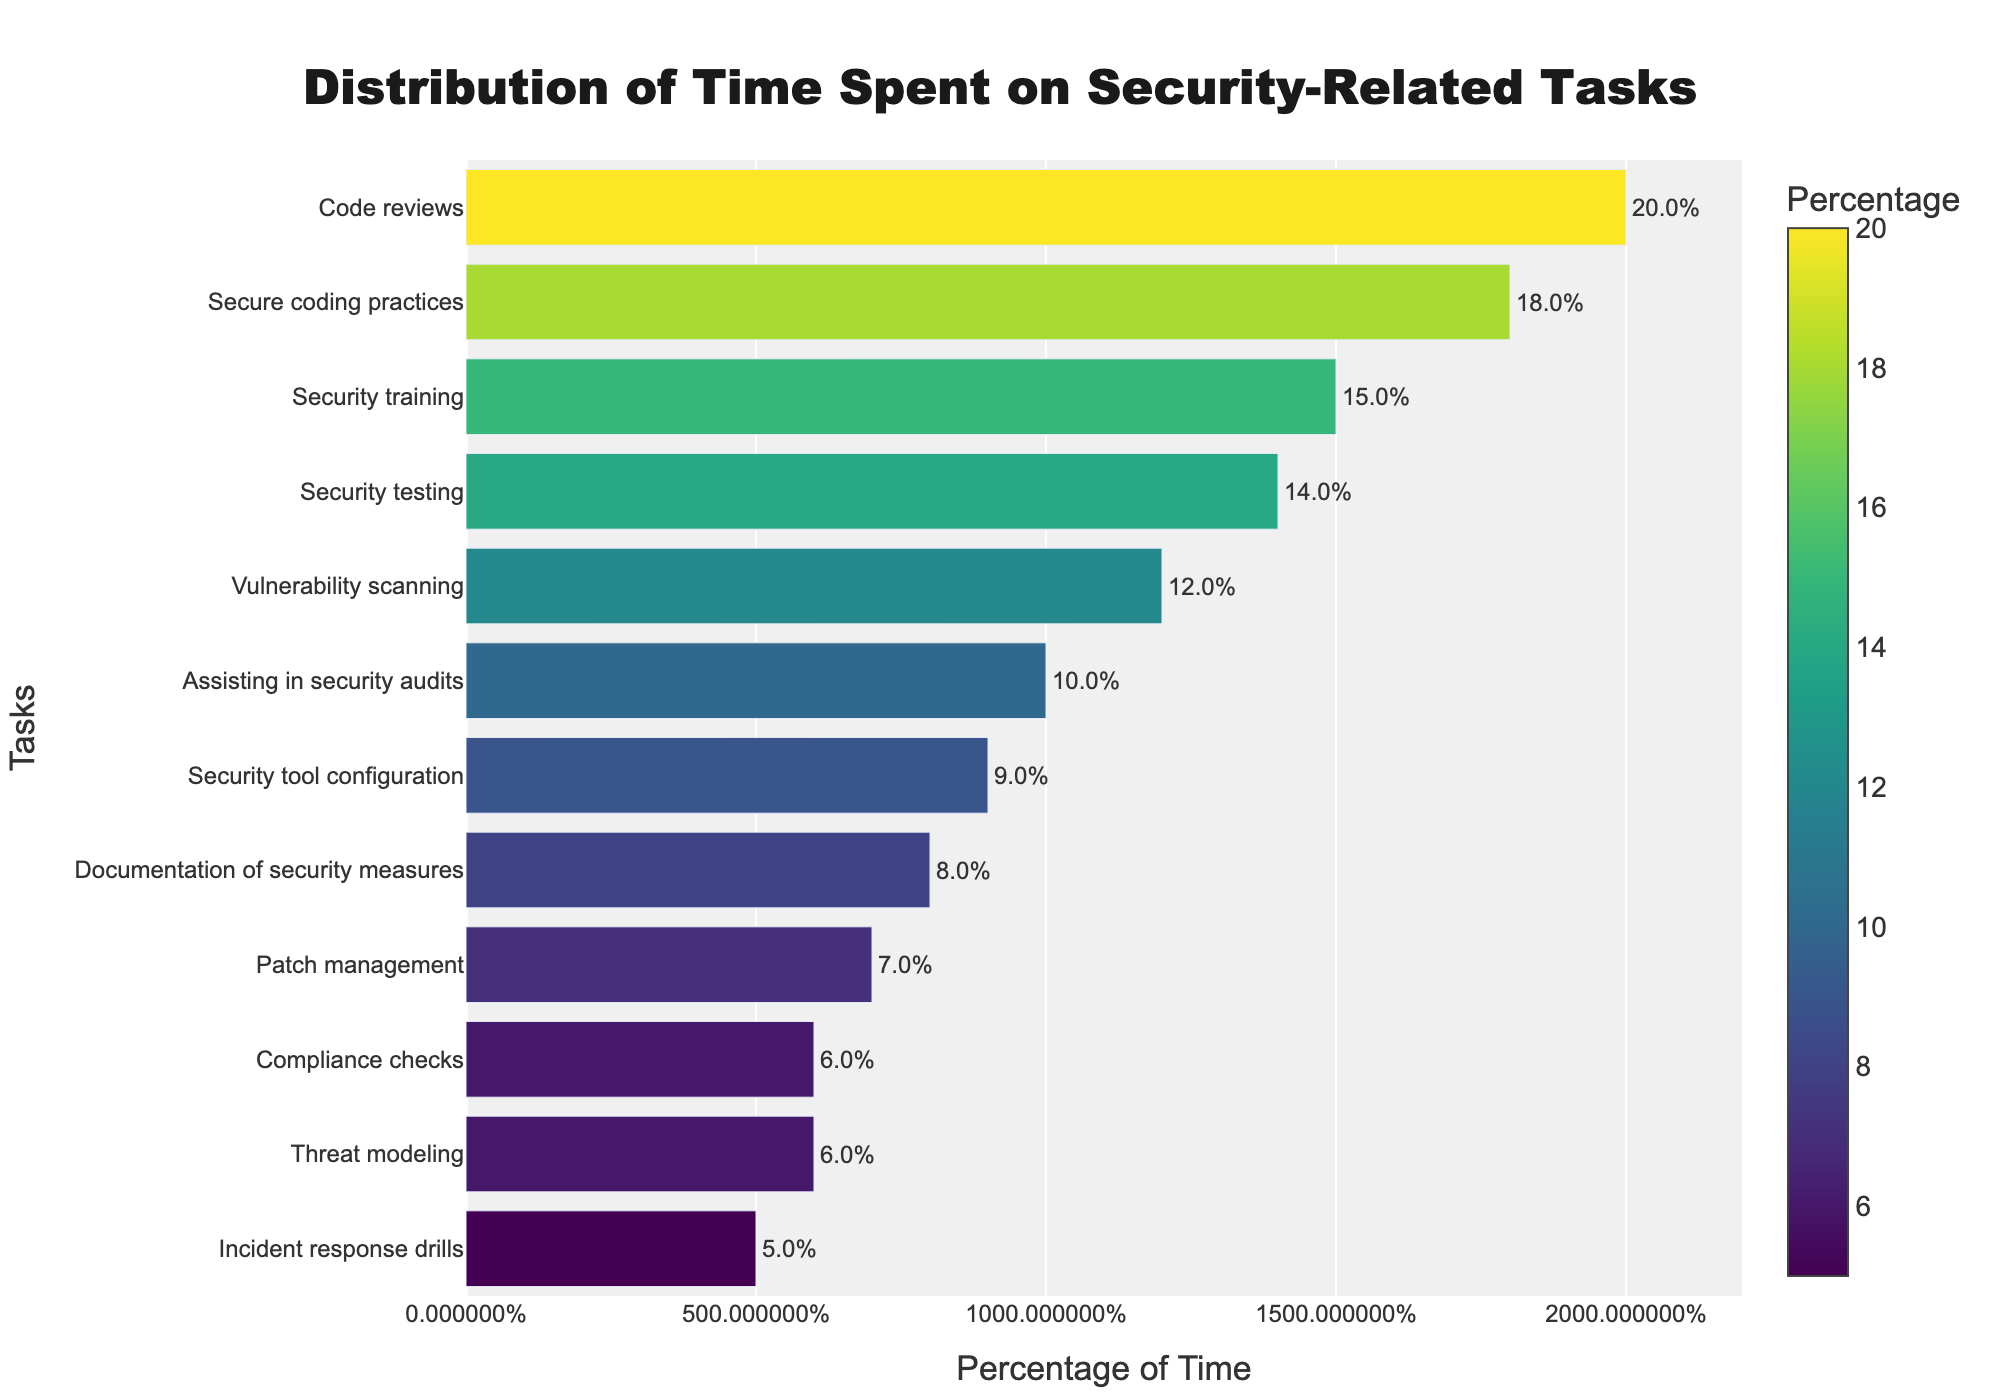what task consumes the most time? From the bar chart, the longest bar represents "Code reviews," which indicates the highest percentage.
Answer: Code reviews Rank the top three tasks based on the time spent. The three longest bars correspond to "Code reviews," "Secure coding practices," and "Security training" in descending order.
Answer: Code reviews, Secure coding practices, Security training Which tasks have the same percentage of time spent? By observing the lengths of the bars and their associated percentages, "Threat modeling" and "Compliance checks" both have a percentage of 6%.
Answer: Threat modeling, Compliance checks What is the combined percentage of time spent on "Security testing" and "Vulnerability scanning"? The bar representing "Security testing" shows 14%, and the bar for "Vulnerability scanning" shows 12%. Adding them together gives 14% + 12% = 26%.
Answer: 26% Which task requires less time: "Incident response drills" or "Patch management"? The bar for "Incident response drills" is shorter and shows 5%, whereas "Patch management" shows 7%. Thus, "Incident response drills" require less time.
Answer: Incident response drills What is the difference in percentage between the time spent on "Code reviews" and "Documentation of security measures"? The bar for "Code reviews" shows 20%, and the bar for "Documentation of security measures" shows 8%. The difference is 20% - 8% = 12%.
Answer: 12% Identify the tasks that take up less than 10% of the time. By looking at the lengths of the bars, the tasks with percentages less than 10% are "Documentation of security measures," "Patch management," "Incident response drills," "Threat modeling," and "Compliance checks."
Answer: Documentation of security measures, Patch management, Incident response drills, Threat modeling, Compliance checks What is the average percentage of time spent on "Assisting in security audits," "Security tool configuration," and "Compliance checks"? The bar for "Assisting in security audits" shows 10%, "Security tool configuration" shows 9%, and "Compliance checks" shows 6%. The average is (10% + 9% + 6%) / 3 = 8.33%.
Answer: 8.33% Which task is associated with the darkest color on the bar chart? The color scale ranges from lighter to darker hues based on the percentage. "Incident response drills" showing 5% is associated with the darkest color.
Answer: Incident response drills 